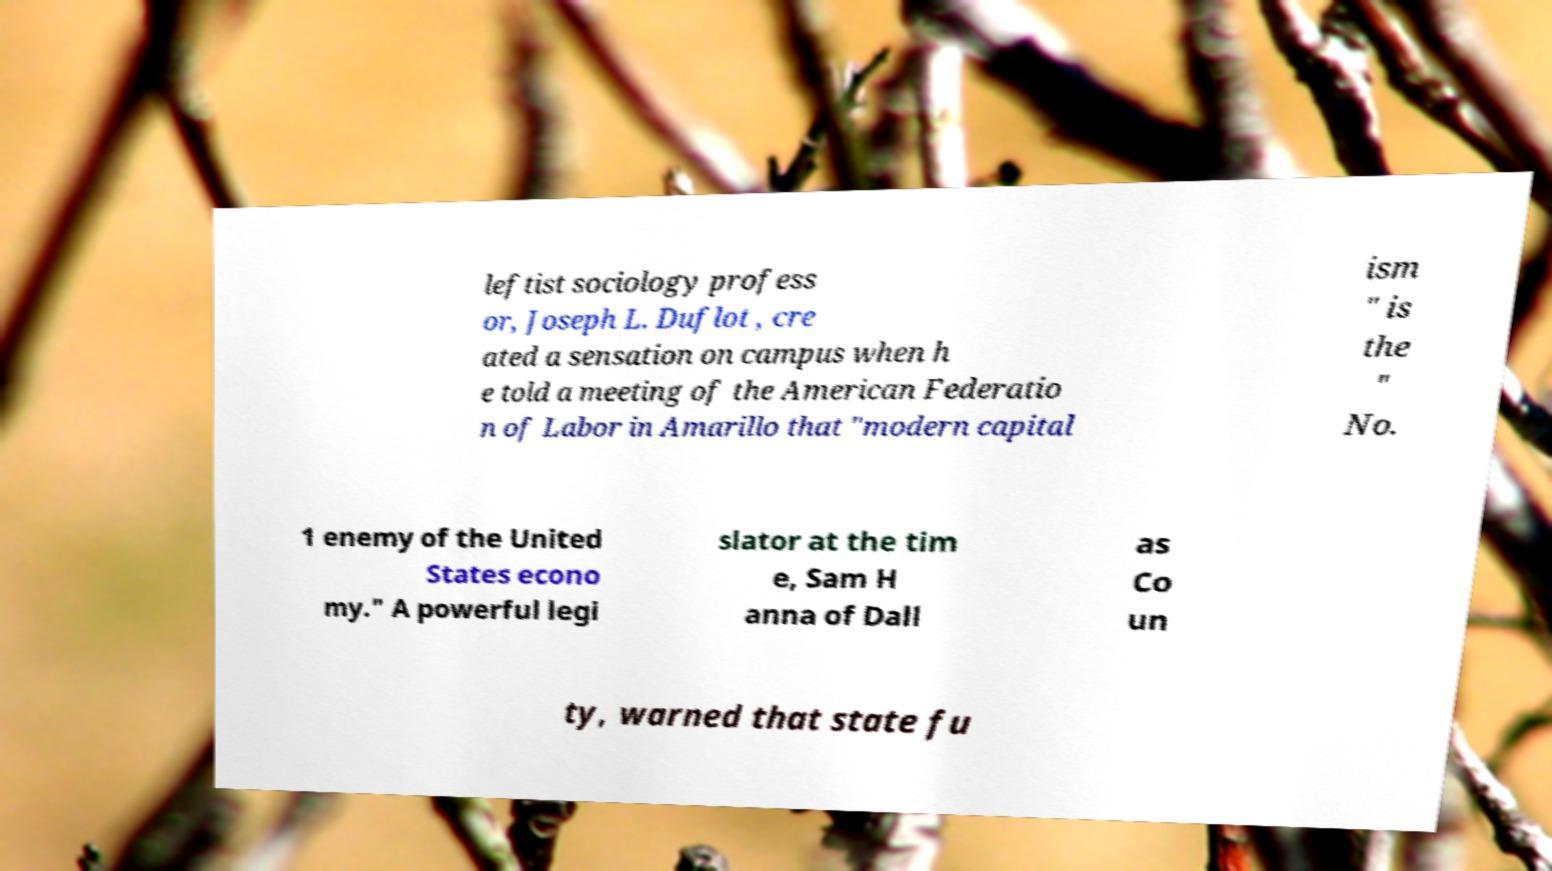Could you assist in decoding the text presented in this image and type it out clearly? leftist sociology profess or, Joseph L. Duflot , cre ated a sensation on campus when h e told a meeting of the American Federatio n of Labor in Amarillo that "modern capital ism " is the " No. 1 enemy of the United States econo my." A powerful legi slator at the tim e, Sam H anna of Dall as Co un ty, warned that state fu 